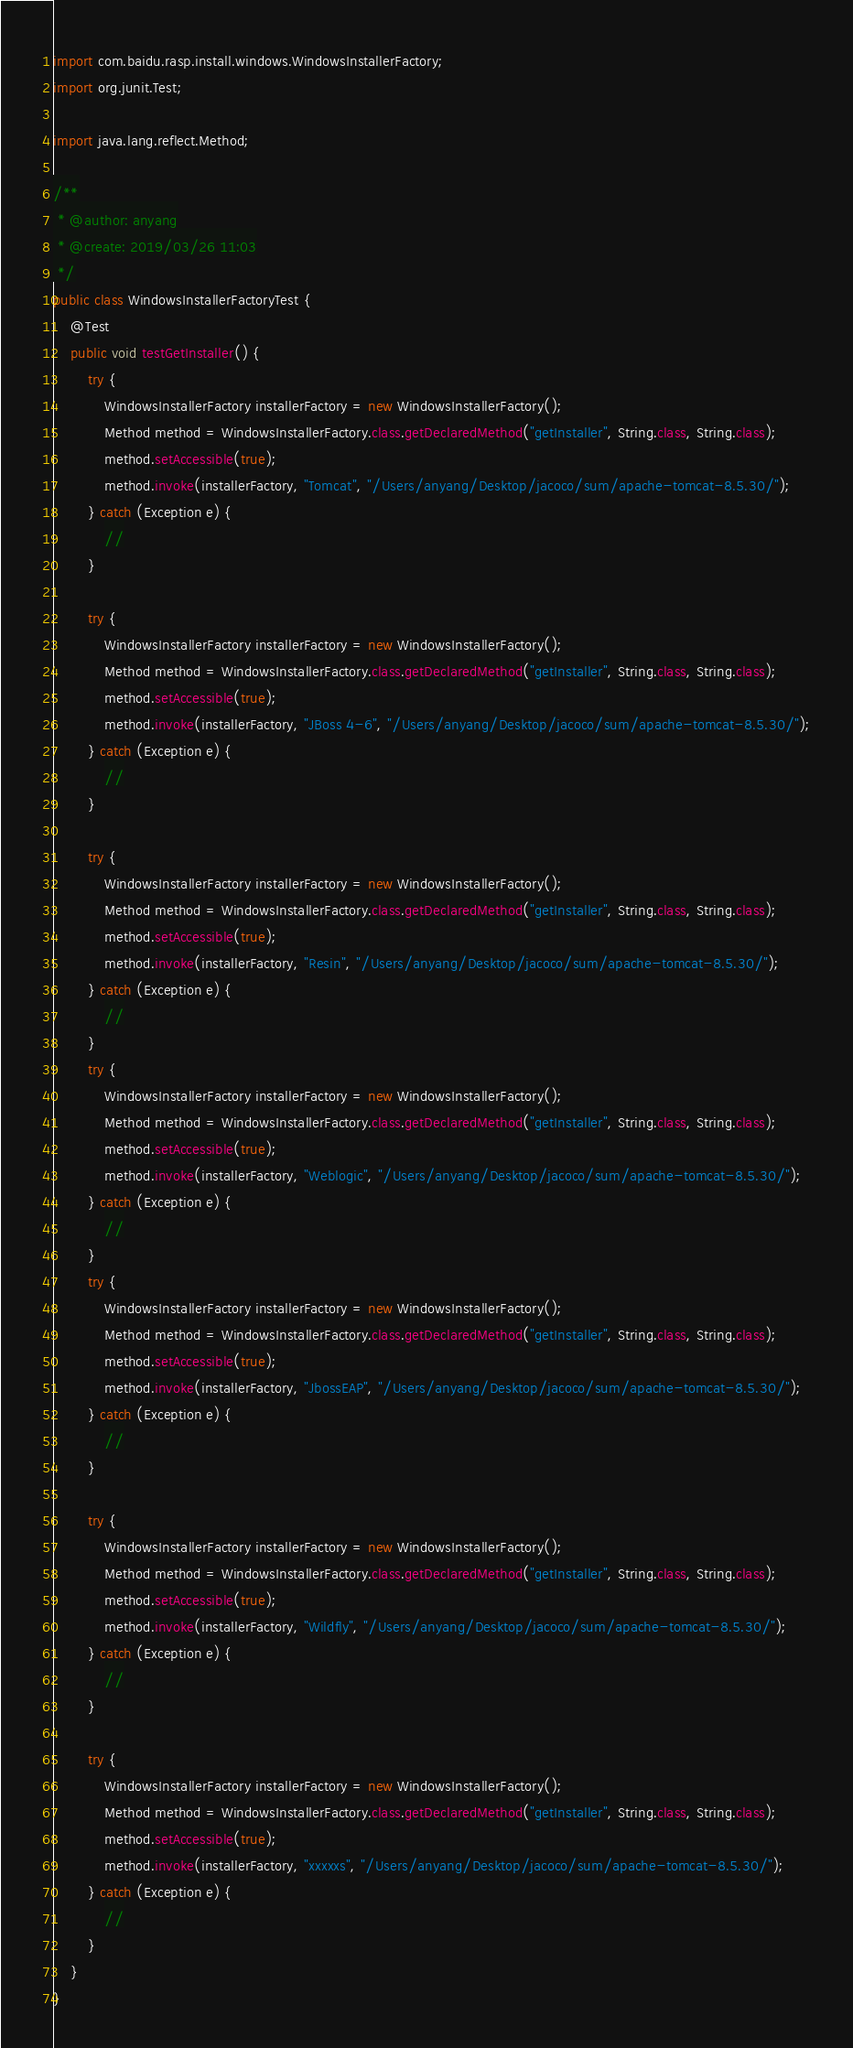Convert code to text. <code><loc_0><loc_0><loc_500><loc_500><_Java_>import com.baidu.rasp.install.windows.WindowsInstallerFactory;
import org.junit.Test;

import java.lang.reflect.Method;

/**
 * @author: anyang
 * @create: 2019/03/26 11:03
 */
public class WindowsInstallerFactoryTest {
    @Test
    public void testGetInstaller() {
        try {
            WindowsInstallerFactory installerFactory = new WindowsInstallerFactory();
            Method method = WindowsInstallerFactory.class.getDeclaredMethod("getInstaller", String.class, String.class);
            method.setAccessible(true);
            method.invoke(installerFactory, "Tomcat", "/Users/anyang/Desktop/jacoco/sum/apache-tomcat-8.5.30/");
        } catch (Exception e) {
            //
        }

        try {
            WindowsInstallerFactory installerFactory = new WindowsInstallerFactory();
            Method method = WindowsInstallerFactory.class.getDeclaredMethod("getInstaller", String.class, String.class);
            method.setAccessible(true);
            method.invoke(installerFactory, "JBoss 4-6", "/Users/anyang/Desktop/jacoco/sum/apache-tomcat-8.5.30/");
        } catch (Exception e) {
            //
        }

        try {
            WindowsInstallerFactory installerFactory = new WindowsInstallerFactory();
            Method method = WindowsInstallerFactory.class.getDeclaredMethod("getInstaller", String.class, String.class);
            method.setAccessible(true);
            method.invoke(installerFactory, "Resin", "/Users/anyang/Desktop/jacoco/sum/apache-tomcat-8.5.30/");
        } catch (Exception e) {
            //
        }
        try {
            WindowsInstallerFactory installerFactory = new WindowsInstallerFactory();
            Method method = WindowsInstallerFactory.class.getDeclaredMethod("getInstaller", String.class, String.class);
            method.setAccessible(true);
            method.invoke(installerFactory, "Weblogic", "/Users/anyang/Desktop/jacoco/sum/apache-tomcat-8.5.30/");
        } catch (Exception e) {
            //
        }
        try {
            WindowsInstallerFactory installerFactory = new WindowsInstallerFactory();
            Method method = WindowsInstallerFactory.class.getDeclaredMethod("getInstaller", String.class, String.class);
            method.setAccessible(true);
            method.invoke(installerFactory, "JbossEAP", "/Users/anyang/Desktop/jacoco/sum/apache-tomcat-8.5.30/");
        } catch (Exception e) {
            //
        }

        try {
            WindowsInstallerFactory installerFactory = new WindowsInstallerFactory();
            Method method = WindowsInstallerFactory.class.getDeclaredMethod("getInstaller", String.class, String.class);
            method.setAccessible(true);
            method.invoke(installerFactory, "Wildfly", "/Users/anyang/Desktop/jacoco/sum/apache-tomcat-8.5.30/");
        } catch (Exception e) {
            //
        }

        try {
            WindowsInstallerFactory installerFactory = new WindowsInstallerFactory();
            Method method = WindowsInstallerFactory.class.getDeclaredMethod("getInstaller", String.class, String.class);
            method.setAccessible(true);
            method.invoke(installerFactory, "xxxxxs", "/Users/anyang/Desktop/jacoco/sum/apache-tomcat-8.5.30/");
        } catch (Exception e) {
            //
        }
    }
}
</code> 